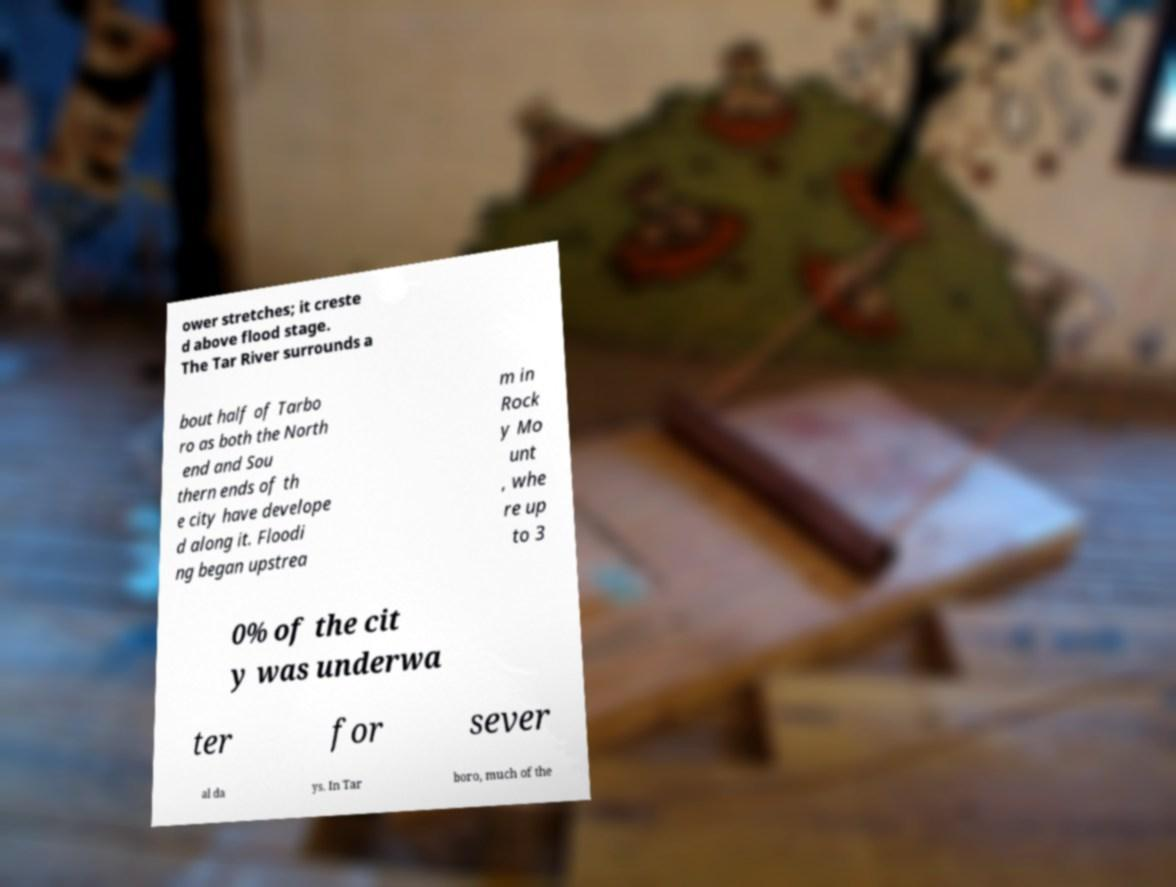Could you extract and type out the text from this image? ower stretches; it creste d above flood stage. The Tar River surrounds a bout half of Tarbo ro as both the North end and Sou thern ends of th e city have develope d along it. Floodi ng began upstrea m in Rock y Mo unt , whe re up to 3 0% of the cit y was underwa ter for sever al da ys. In Tar boro, much of the 